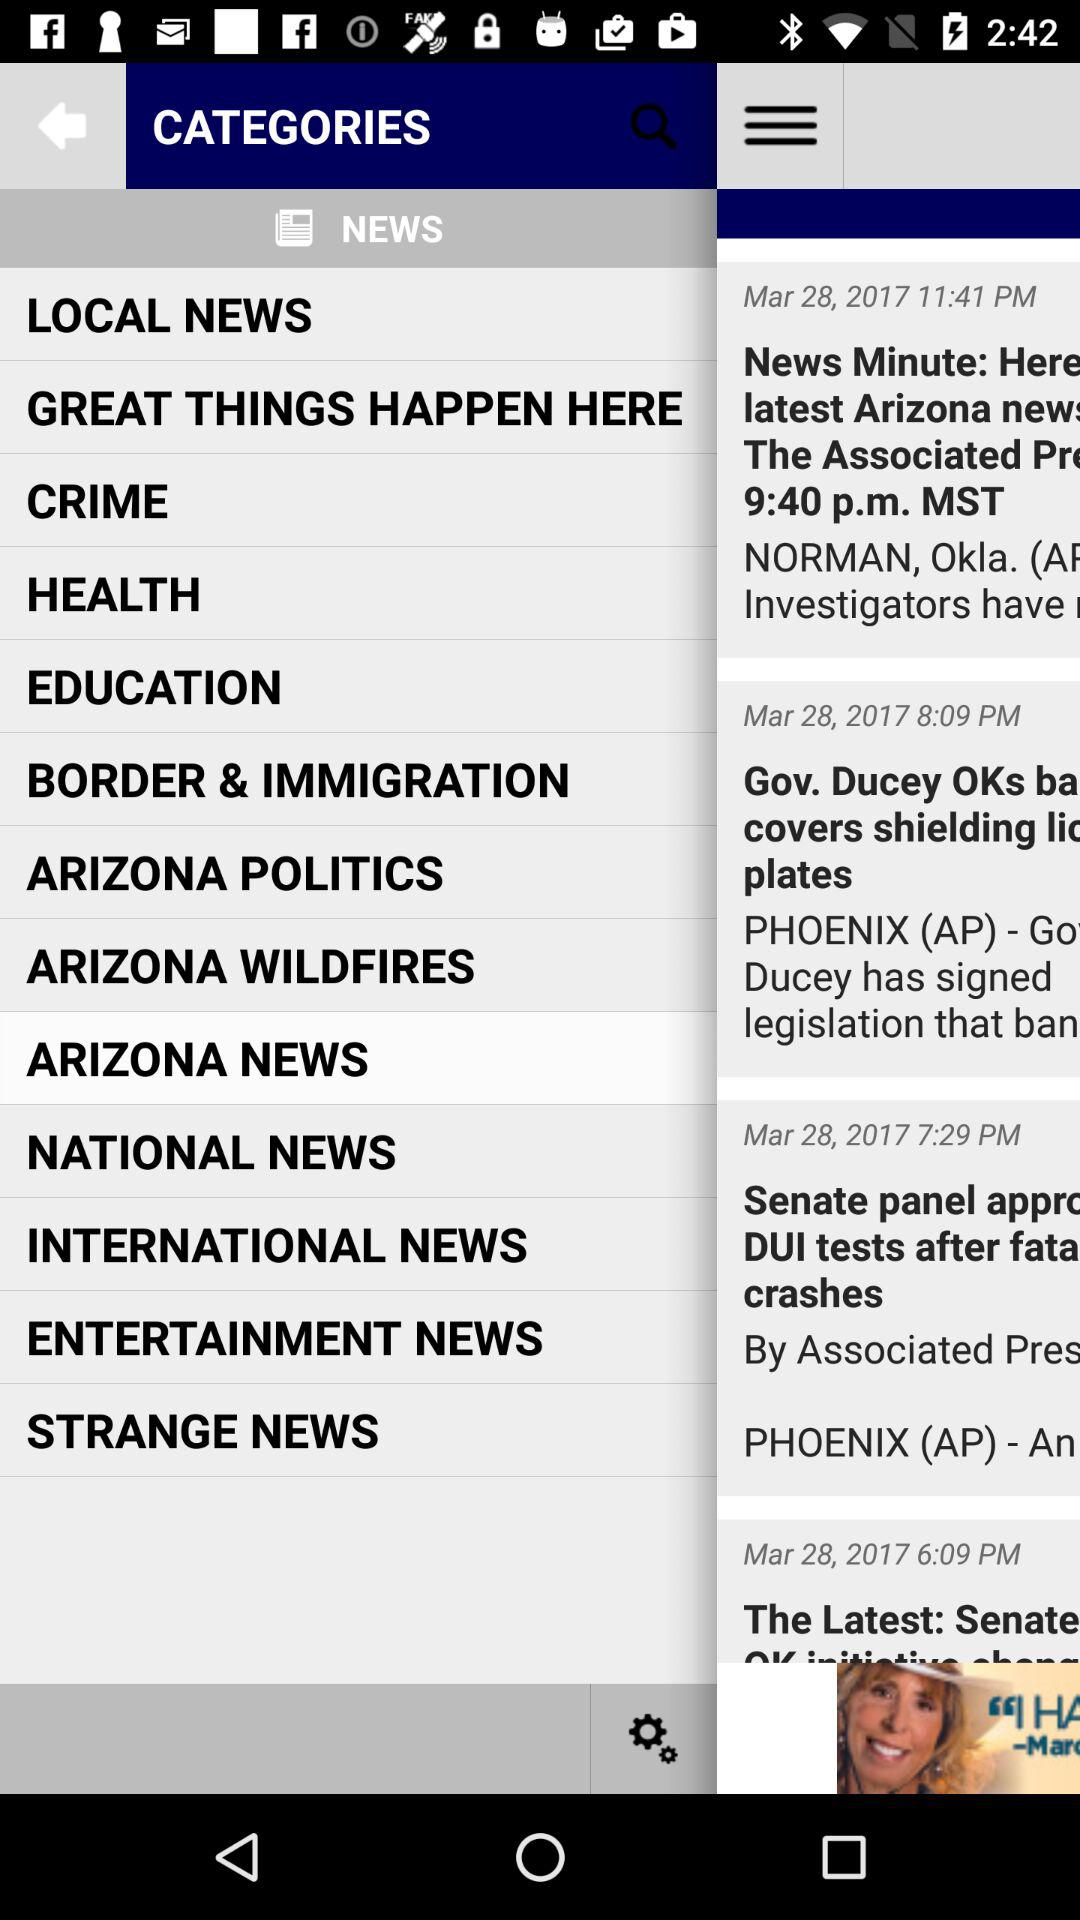What's the selected news category? The selected news category is "ARIZONA NEWS". 